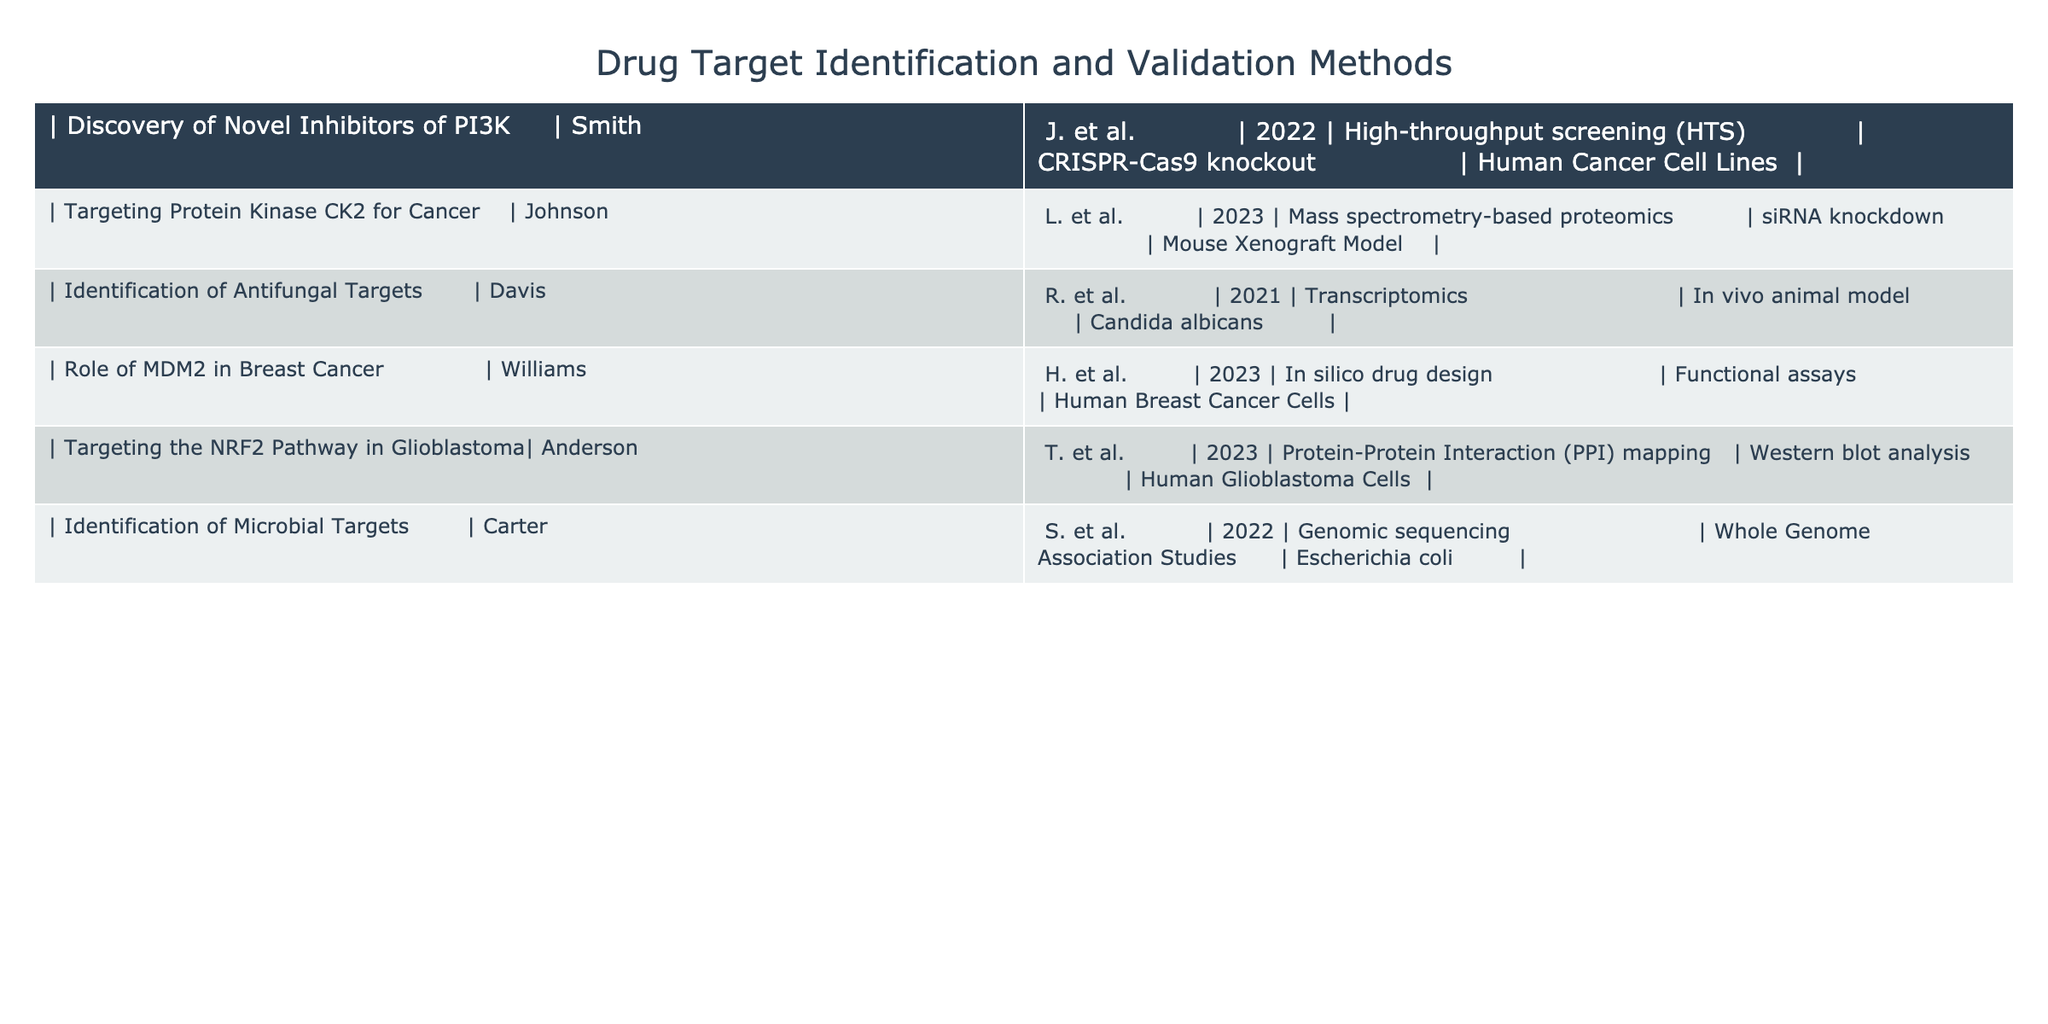What drug target identification method was used in the study by Johnson, L. et al.? The table indicates that Johnson, L. et al. (2023) used mass spectrometry-based proteomics for drug target identification.
Answer: Mass spectrometry-based proteomics Which study used human cancer cell lines for validation? The table shows that the study by Smith, J. et al. (2022) is the one that used human cancer cell lines for validation.
Answer: Smith, J. et al Is there a study that uses CRISPR-Cas9 knockout as a validation method? Yes, according to the table, Smith, J. et al. (2022) used CRISPR-Cas9 knockout for validation.
Answer: Yes What is the earliest year mentioned in the table? The earliest study in the table is by Davis, R. et al., published in 2021, making it the earliest year listed.
Answer: 2021 Which method was used by Williams, H. et al. in 2023 for drug target identification? Williams, H. et al. (2023) utilized in silico drug design for drug target identification as per the table.
Answer: In silico drug design Which studies employed in vivo models for validation? The table shows that both Davis, R. et al. (2021) and Johnson, L. et al. (2023) used in vivo animal models for validation.
Answer: Davis, R. et al. and Johnson, L. et al How many studies used mass spectrometry-based proteomics? Only one study, conducted by Johnson, L. et al. (2023), used mass spectrometry-based proteomics, as per the table.
Answer: One study What is the difference in the types of cell lines used between Smith, J. et al. and Anderson, T. et al.? Smith, J. et al. (2022) used human cancer cell lines, while Anderson, T. et al. (2023) used human glioblastoma cells; thus, both were human cell lines but from different cancer types.
Answer: They are both human cell lines from different cancer types Which study reports using genomic sequencing for target identification? According to the table, the study by Carter, S. et al. (2022) is the one that reports the use of genomic sequencing for target identification.
Answer: Carter, S. et al 